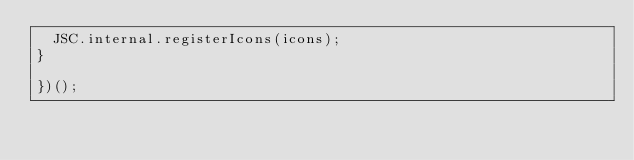Convert code to text. <code><loc_0><loc_0><loc_500><loc_500><_JavaScript_>	JSC.internal.registerIcons(icons);
}

})();</code> 